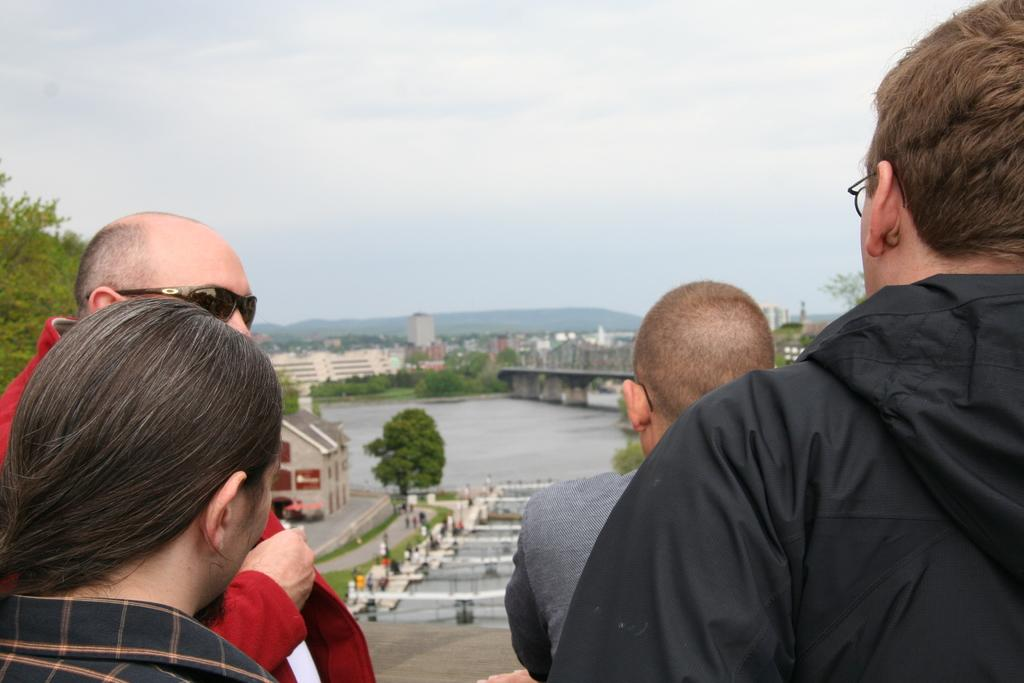How many people are in the foreground of the image? There are four people in the foreground of the image. What can be seen in the background of the image? In the background of the image, there are bridges, water, trees, buildings, a mountain, and the sky. Can you describe the sky in the image? The sky in the image is visible and has clouds. What type of patch is being sewn onto the person's clothing in the image? There is no patch visible on anyone's clothing in the image. How many times does the person in the image sneeze? There is no indication of anyone sneezing in the image. 